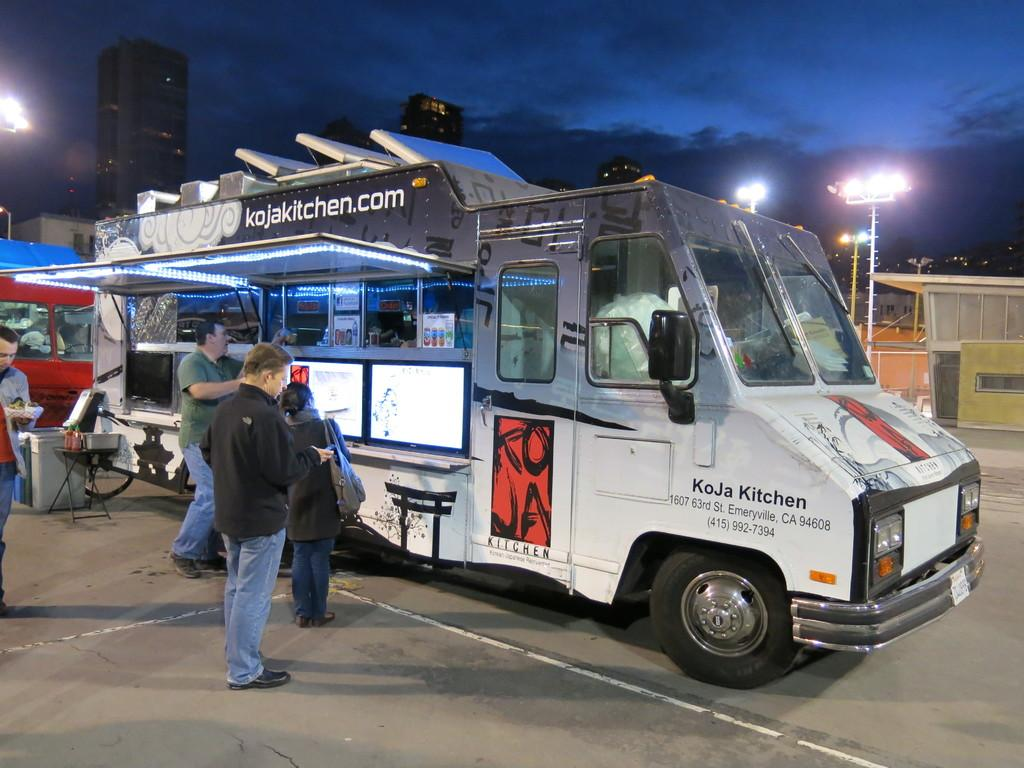<image>
Present a compact description of the photo's key features. A food truck from kojakitchen has a few customers outside. 